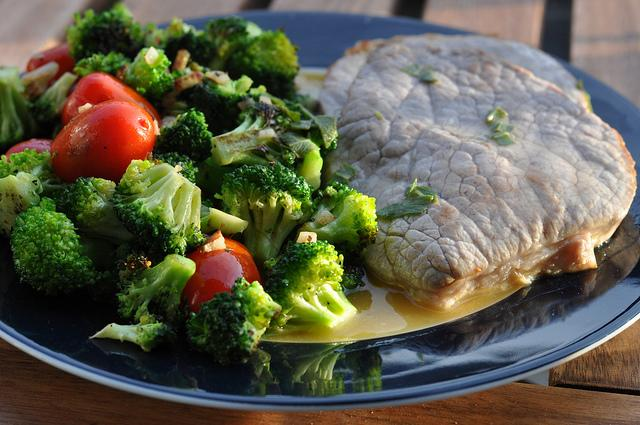What variety of tomato is on the plate? cherry 